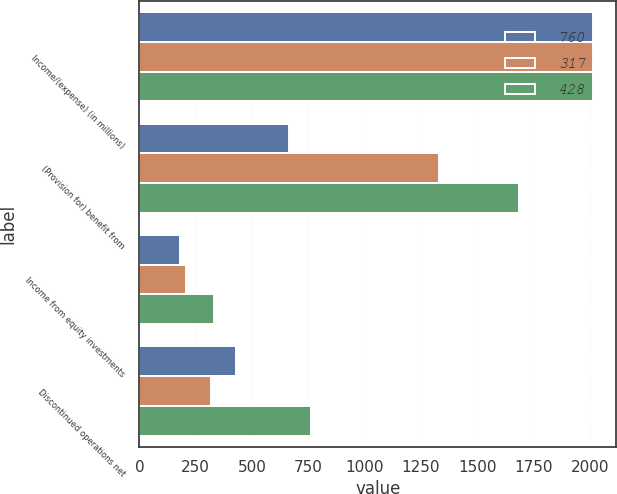Convert chart. <chart><loc_0><loc_0><loc_500><loc_500><stacked_bar_chart><ecel><fcel>Income/(expense) (in millions)<fcel>(Provision for) benefit from<fcel>Income from equity investments<fcel>Discontinued operations net<nl><fcel>760<fcel>2016<fcel>662<fcel>181<fcel>428<nl><fcel>317<fcel>2015<fcel>1330<fcel>208<fcel>317<nl><fcel>428<fcel>2014<fcel>1685<fcel>331<fcel>760<nl></chart> 